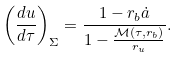<formula> <loc_0><loc_0><loc_500><loc_500>\left ( \frac { d u } { d \tau } \right ) _ { \Sigma } = \frac { 1 - r _ { b } \dot { a } } { 1 - \frac { { \mathcal { M } } ( \tau , r _ { b } ) } { r _ { u } } } .</formula> 